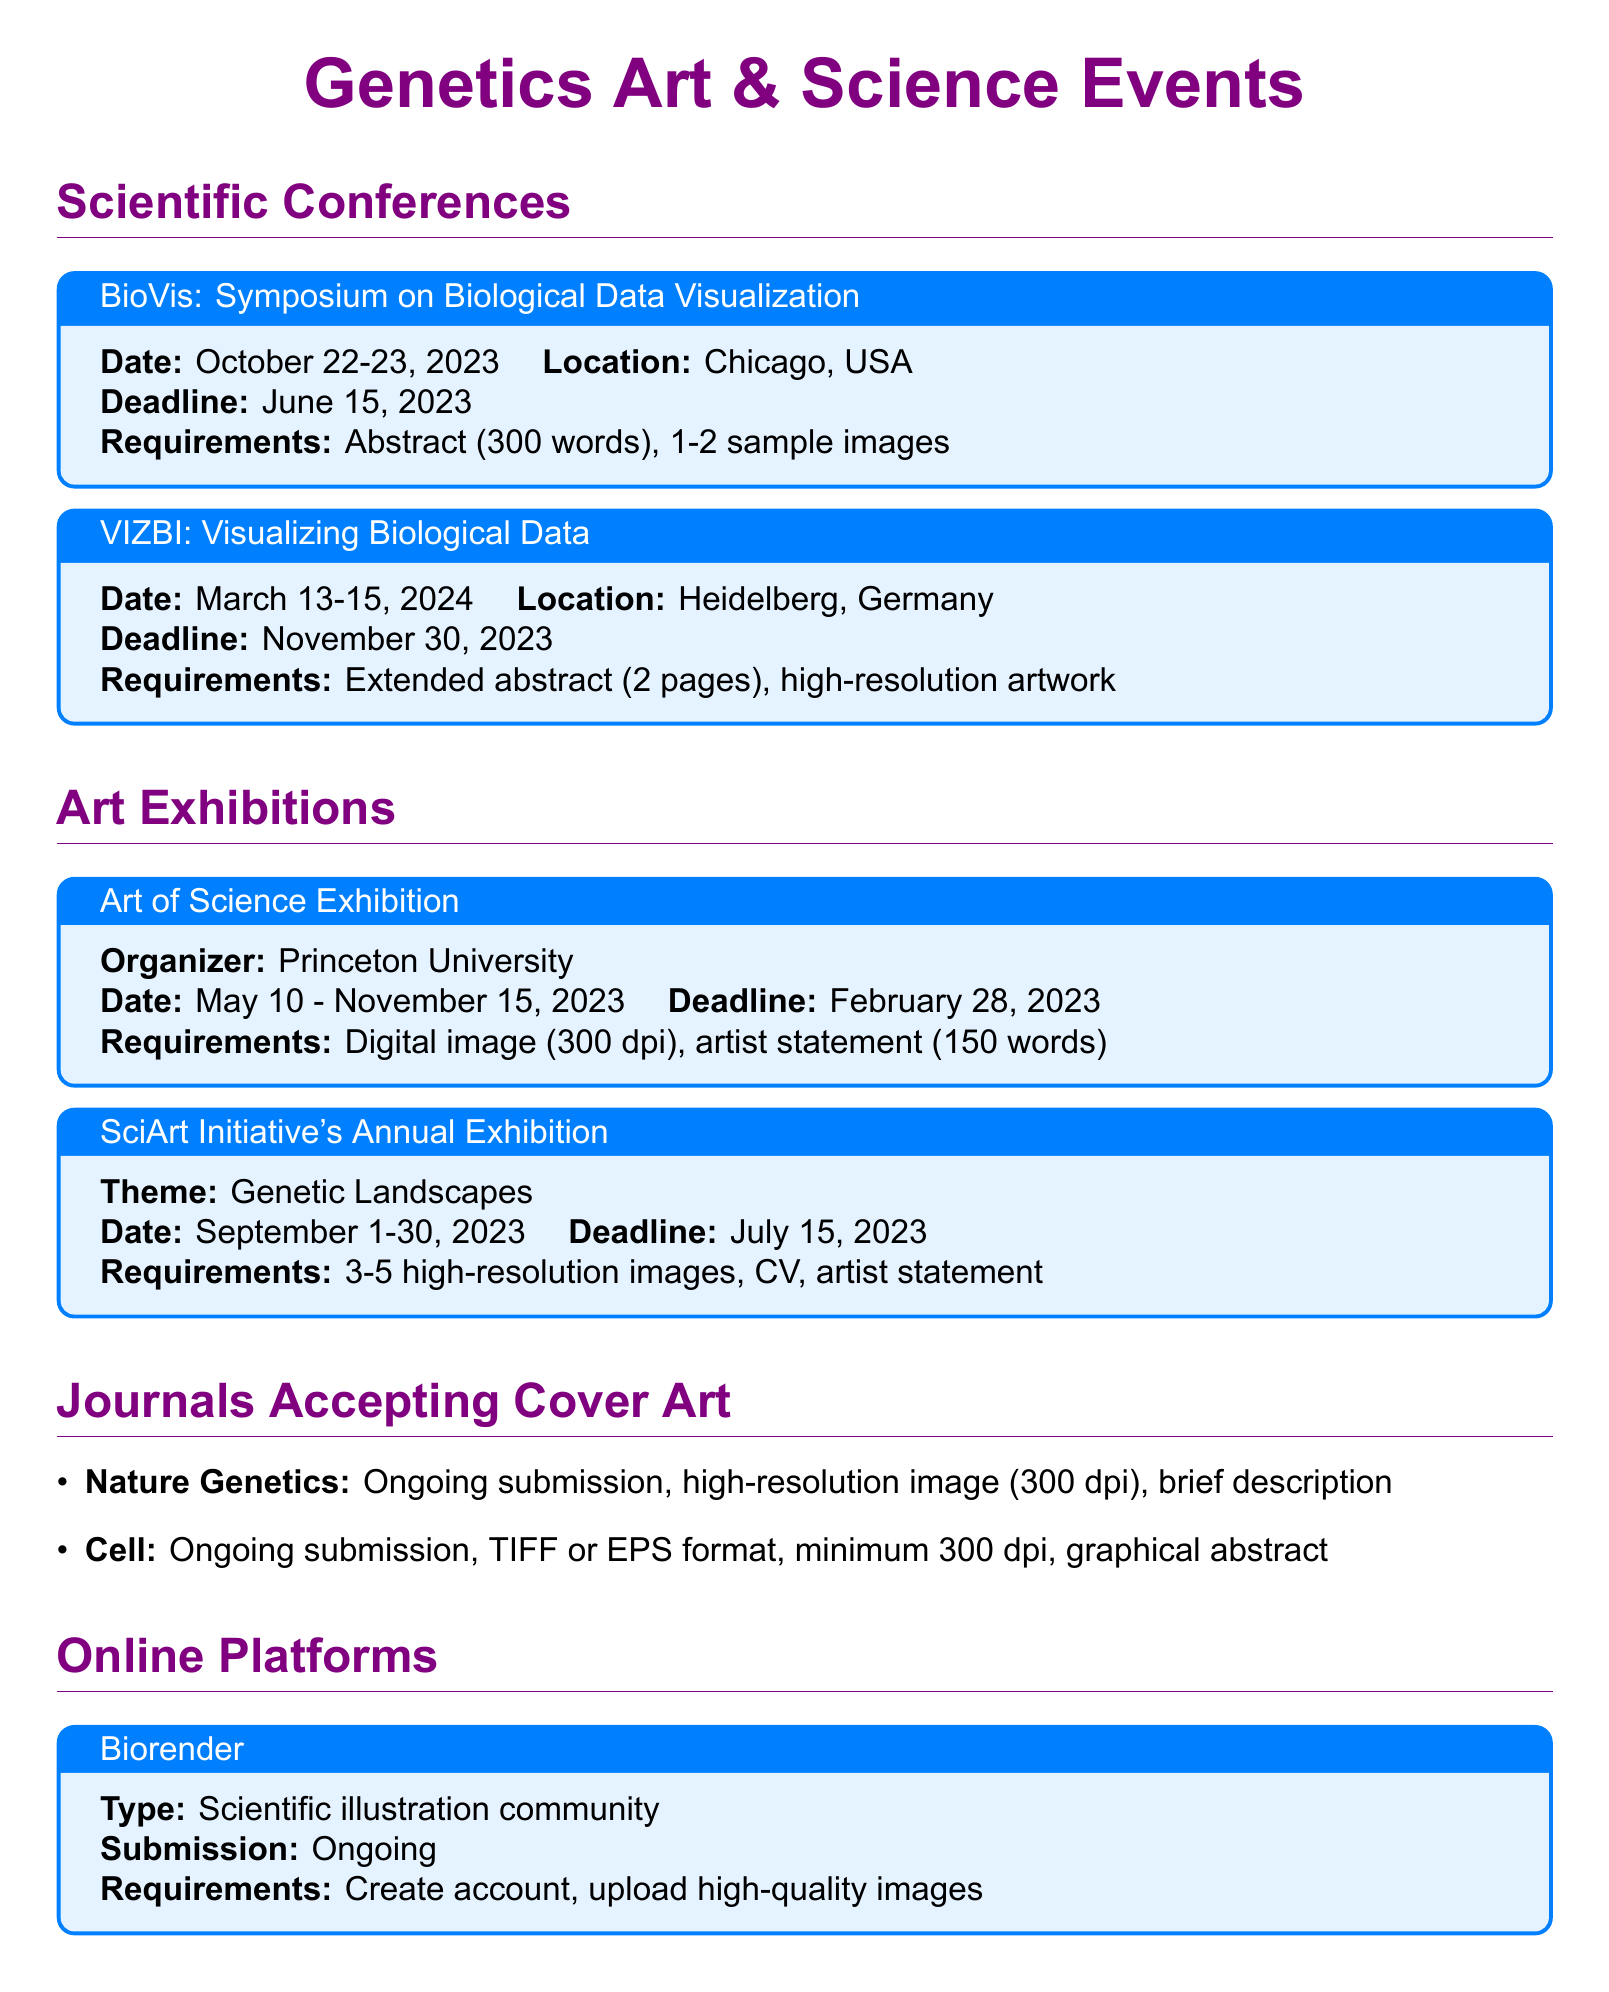what is the date of the BioVis symposium? The date of the BioVis symposium is specified in the document as October 22-23, 2023.
Answer: October 22-23, 2023 where is the VIZBI conference located? The location of the VIZBI conference is mentioned in the document as Heidelberg, Germany.
Answer: Heidelberg, Germany what is the deadline for the SciArt Initiative's Annual Exhibition? The deadline for the SciArt Initiative's Annual Exhibition is found in the document as July 15, 2023.
Answer: July 15, 2023 how many high-resolution images are required for the Art of Science Exhibition? The number of high-resolution images required is part of the submission requirements detailed in the document, which states it is a digital image (300 dpi).
Answer: 1 what must be included with the Nature Genetics submission? The document specifies the requirements for Nature Genetics submissions, which includes a high-resolution image and a brief description.
Answer: High-resolution image, brief description which exhibition has a theme related to genetics? The document indicates that the SciArt Initiative's Annual Exhibition has a theme of Genetic Landscapes, linking it directly to genetics.
Answer: Genetic Landscapes how many sample images are required for the BioVis symposium? The document lists the requirements for the BioVis symposium, which includes 1-2 sample images.
Answer: 1-2 what type of files does the journal Cell accept for submission? According to the document, the journal Cell accepts TIFF or EPS format for its submissions.
Answer: TIFF or EPS format what is the type of Biorender platform? The document describes Biorender as a scientific illustration community, highlighting its focus and purpose.
Answer: Scientific illustration community 